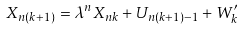<formula> <loc_0><loc_0><loc_500><loc_500>X _ { n ( k + 1 ) } = \lambda ^ { n } X _ { n k } + U _ { n ( k + 1 ) - 1 } + W ^ { \prime } _ { k }</formula> 